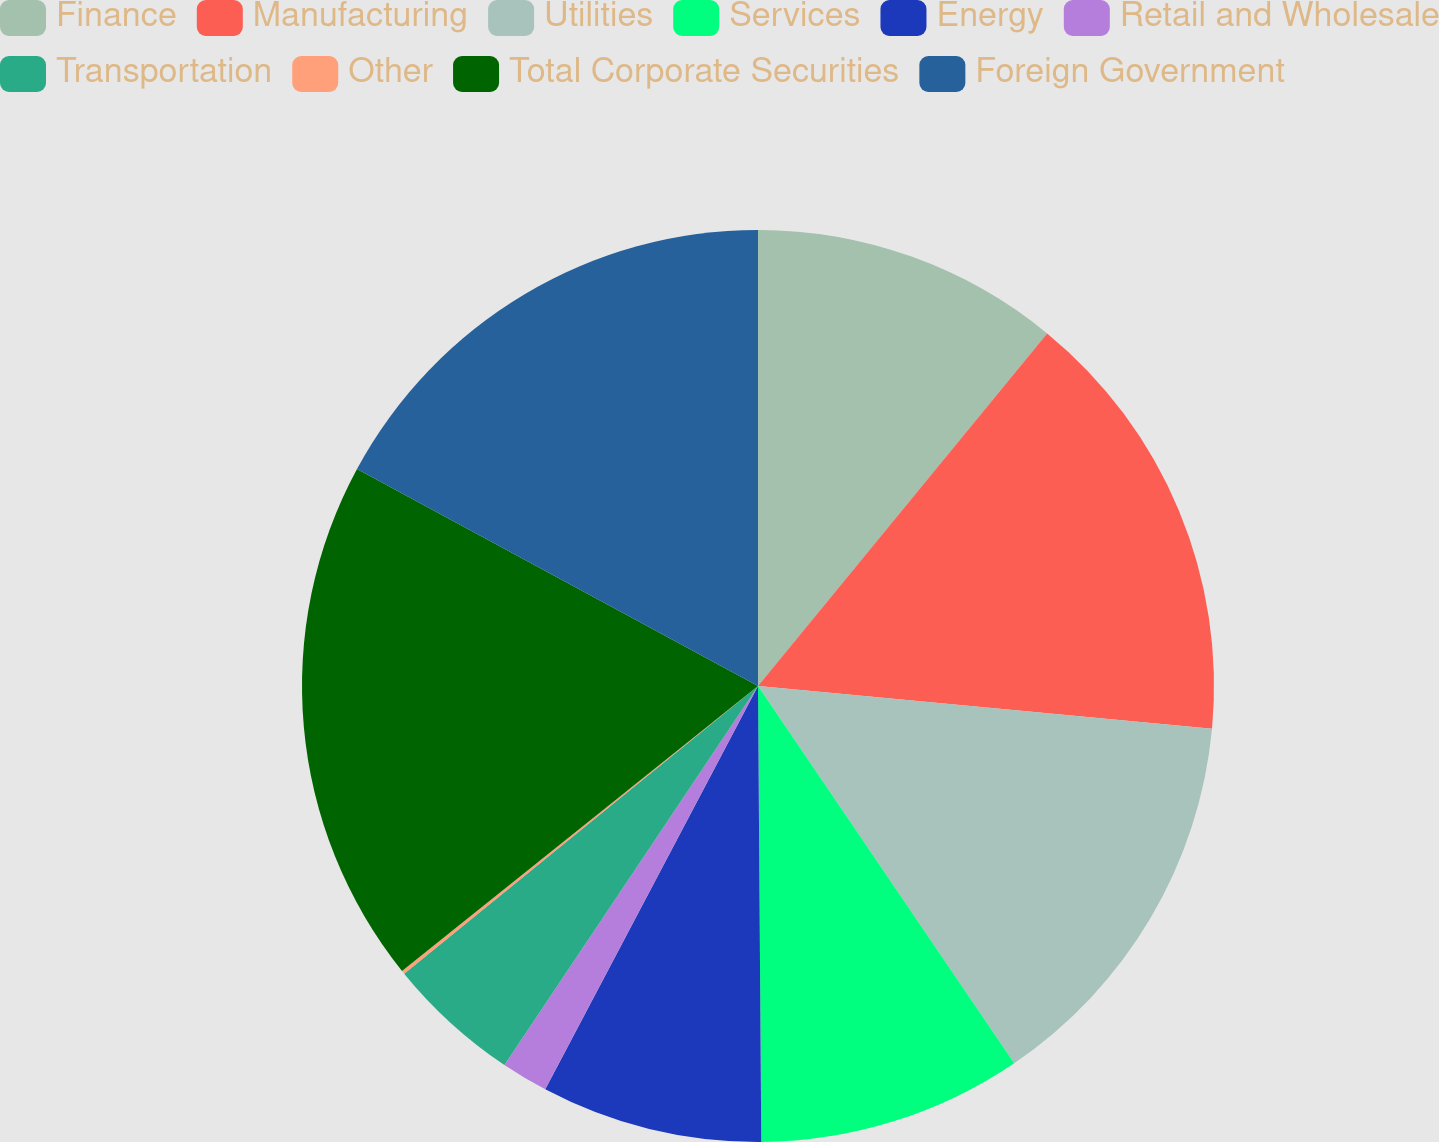Convert chart to OTSL. <chart><loc_0><loc_0><loc_500><loc_500><pie_chart><fcel>Finance<fcel>Manufacturing<fcel>Utilities<fcel>Services<fcel>Energy<fcel>Retail and Wholesale<fcel>Transportation<fcel>Other<fcel>Total Corporate Securities<fcel>Foreign Government<nl><fcel>10.93%<fcel>15.56%<fcel>14.01%<fcel>9.38%<fcel>7.84%<fcel>1.66%<fcel>4.75%<fcel>0.12%<fcel>18.64%<fcel>17.1%<nl></chart> 